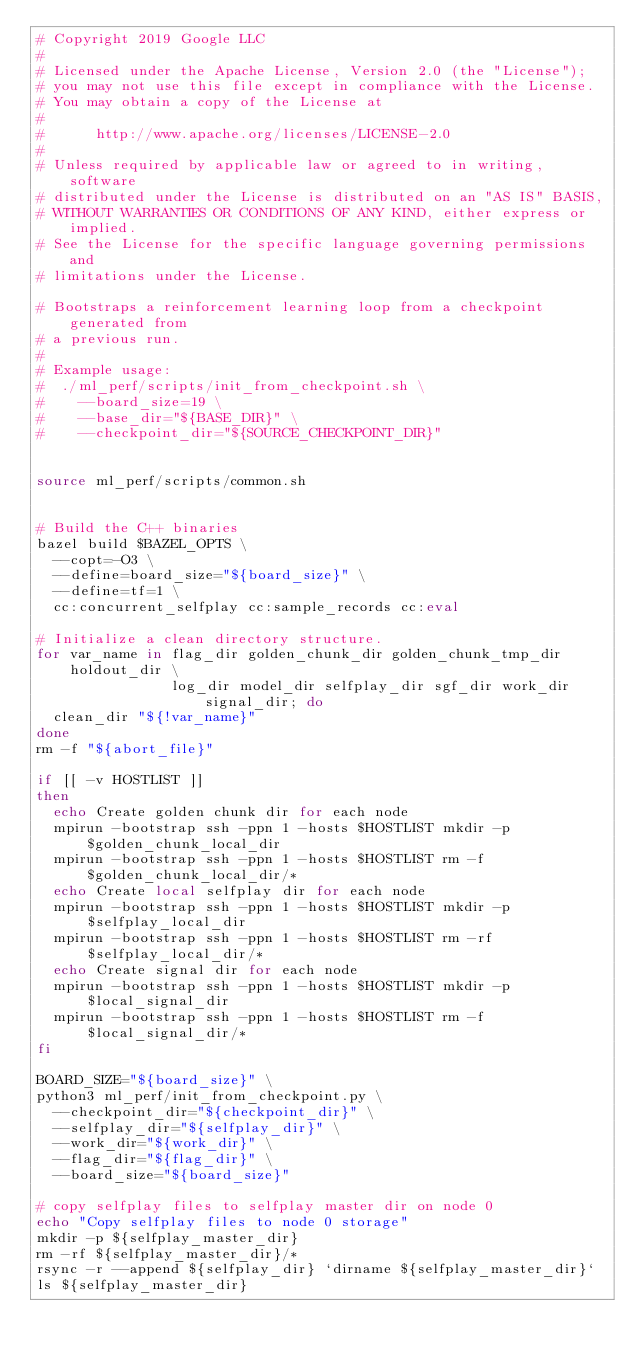<code> <loc_0><loc_0><loc_500><loc_500><_Bash_># Copyright 2019 Google LLC
#
# Licensed under the Apache License, Version 2.0 (the "License");
# you may not use this file except in compliance with the License.
# You may obtain a copy of the License at
#
#      http://www.apache.org/licenses/LICENSE-2.0
#
# Unless required by applicable law or agreed to in writing, software
# distributed under the License is distributed on an "AS IS" BASIS,
# WITHOUT WARRANTIES OR CONDITIONS OF ANY KIND, either express or implied.
# See the License for the specific language governing permissions and
# limitations under the License.

# Bootstraps a reinforcement learning loop from a checkpoint generated from
# a previous run.
#
# Example usage:
#  ./ml_perf/scripts/init_from_checkpoint.sh \
#    --board_size=19 \
#    --base_dir="${BASE_DIR}" \
#    --checkpoint_dir="${SOURCE_CHECKPOINT_DIR}"


source ml_perf/scripts/common.sh


# Build the C++ binaries
bazel build $BAZEL_OPTS \
  --copt=-O3 \
  --define=board_size="${board_size}" \
  --define=tf=1 \
  cc:concurrent_selfplay cc:sample_records cc:eval

# Initialize a clean directory structure.
for var_name in flag_dir golden_chunk_dir golden_chunk_tmp_dir holdout_dir \
                log_dir model_dir selfplay_dir sgf_dir work_dir signal_dir; do
  clean_dir "${!var_name}"
done
rm -f "${abort_file}"

if [[ -v HOSTLIST ]]
then
  echo Create golden chunk dir for each node
  mpirun -bootstrap ssh -ppn 1 -hosts $HOSTLIST mkdir -p $golden_chunk_local_dir
  mpirun -bootstrap ssh -ppn 1 -hosts $HOSTLIST rm -f $golden_chunk_local_dir/*
  echo Create local selfplay dir for each node
  mpirun -bootstrap ssh -ppn 1 -hosts $HOSTLIST mkdir -p $selfplay_local_dir
  mpirun -bootstrap ssh -ppn 1 -hosts $HOSTLIST rm -rf $selfplay_local_dir/*  
  echo Create signal dir for each node
  mpirun -bootstrap ssh -ppn 1 -hosts $HOSTLIST mkdir -p $local_signal_dir
  mpirun -bootstrap ssh -ppn 1 -hosts $HOSTLIST rm -f $local_signal_dir/*
fi

BOARD_SIZE="${board_size}" \
python3 ml_perf/init_from_checkpoint.py \
  --checkpoint_dir="${checkpoint_dir}" \
  --selfplay_dir="${selfplay_dir}" \
  --work_dir="${work_dir}" \
  --flag_dir="${flag_dir}" \
  --board_size="${board_size}"

# copy selfplay files to selfplay master dir on node 0
echo "Copy selfplay files to node 0 storage"
mkdir -p ${selfplay_master_dir}
rm -rf ${selfplay_master_dir}/*
rsync -r --append ${selfplay_dir} `dirname ${selfplay_master_dir}`
ls ${selfplay_master_dir}
</code> 